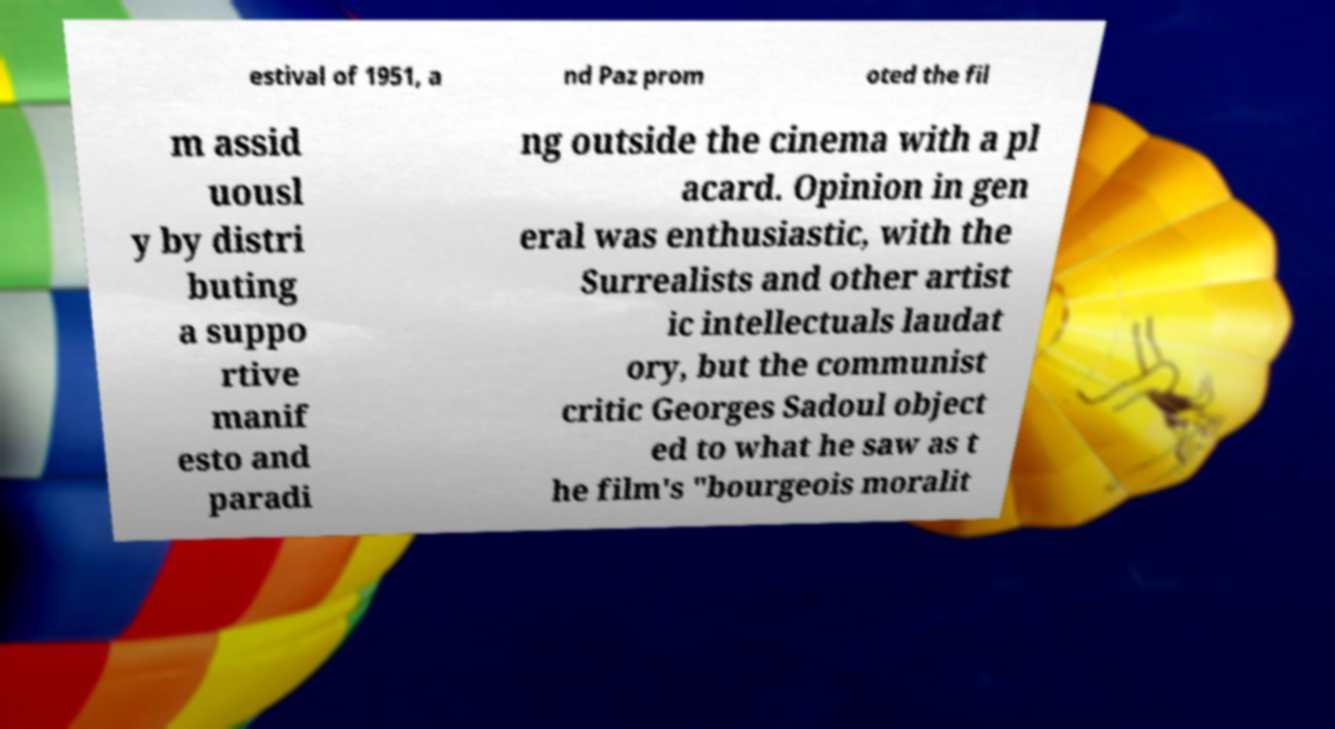There's text embedded in this image that I need extracted. Can you transcribe it verbatim? estival of 1951, a nd Paz prom oted the fil m assid uousl y by distri buting a suppo rtive manif esto and paradi ng outside the cinema with a pl acard. Opinion in gen eral was enthusiastic, with the Surrealists and other artist ic intellectuals laudat ory, but the communist critic Georges Sadoul object ed to what he saw as t he film's "bourgeois moralit 